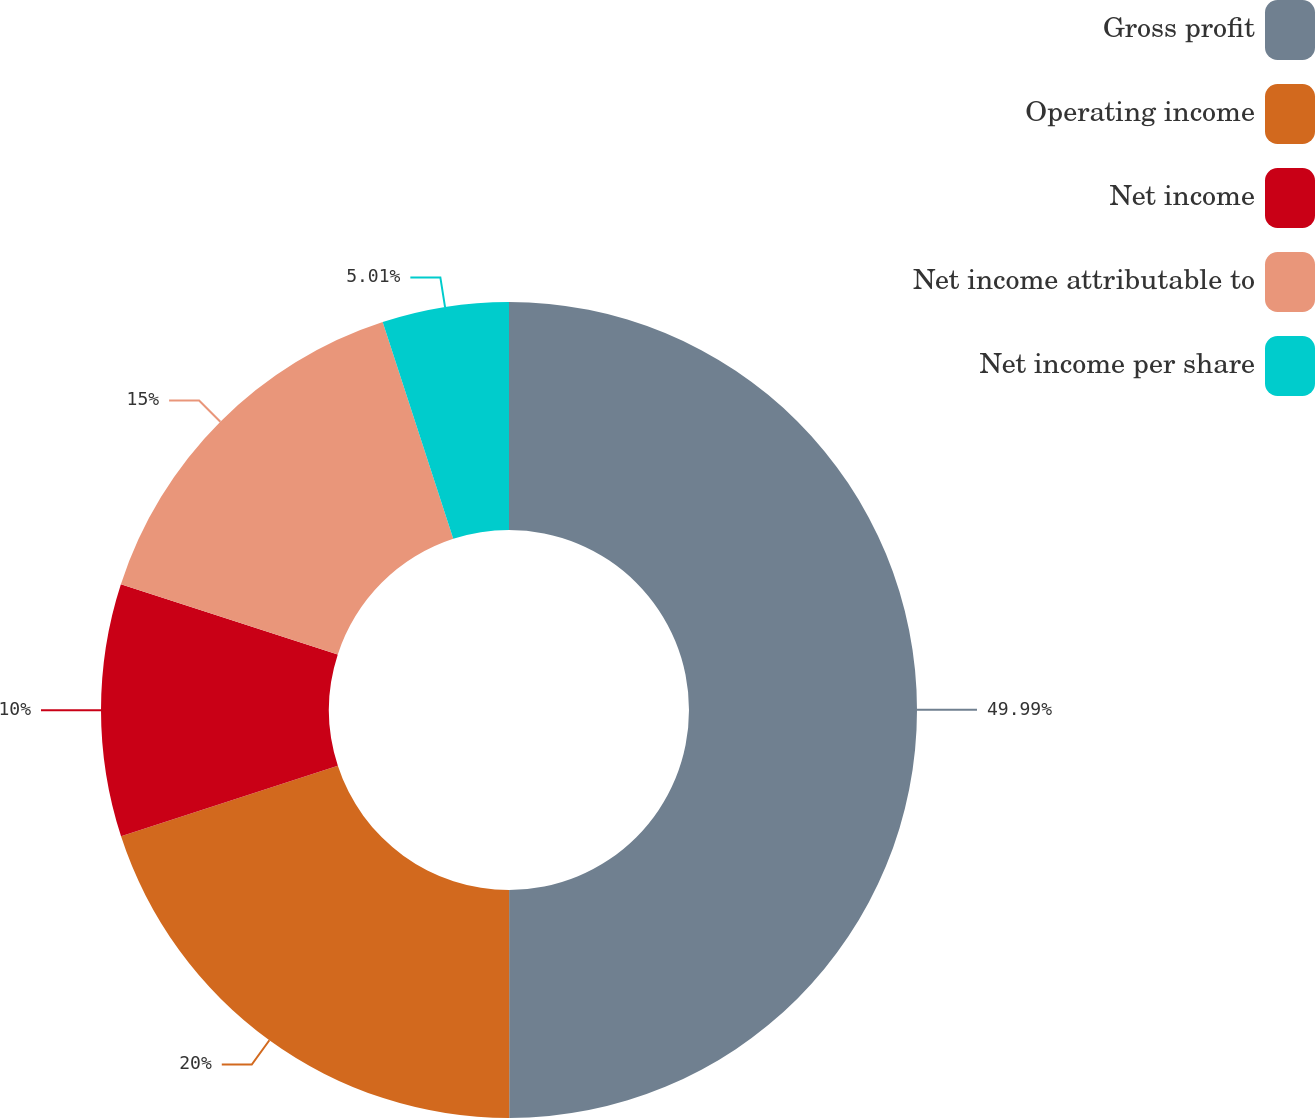Convert chart. <chart><loc_0><loc_0><loc_500><loc_500><pie_chart><fcel>Gross profit<fcel>Operating income<fcel>Net income<fcel>Net income attributable to<fcel>Net income per share<nl><fcel>49.99%<fcel>20.0%<fcel>10.0%<fcel>15.0%<fcel>5.01%<nl></chart> 